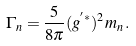<formula> <loc_0><loc_0><loc_500><loc_500>\Gamma _ { n } = \frac { 5 } { 8 \pi } ( g ^ { ^ { \prime } * } ) ^ { 2 } m _ { n } \, .</formula> 